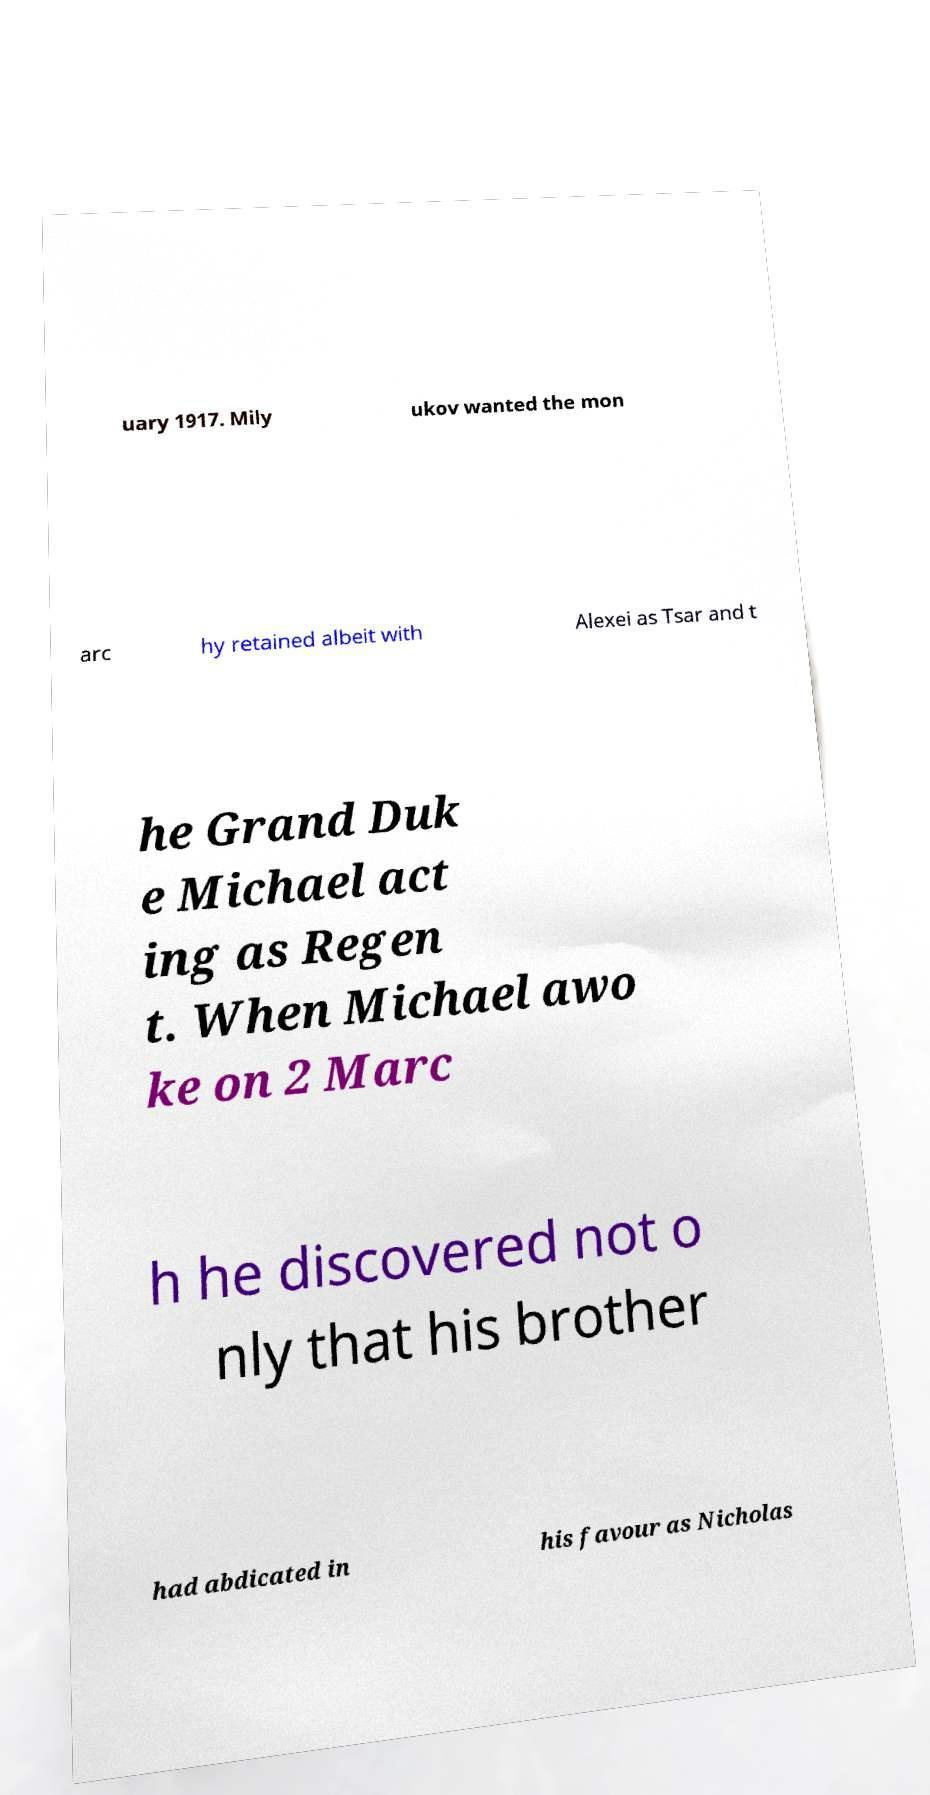There's text embedded in this image that I need extracted. Can you transcribe it verbatim? uary 1917. Mily ukov wanted the mon arc hy retained albeit with Alexei as Tsar and t he Grand Duk e Michael act ing as Regen t. When Michael awo ke on 2 Marc h he discovered not o nly that his brother had abdicated in his favour as Nicholas 